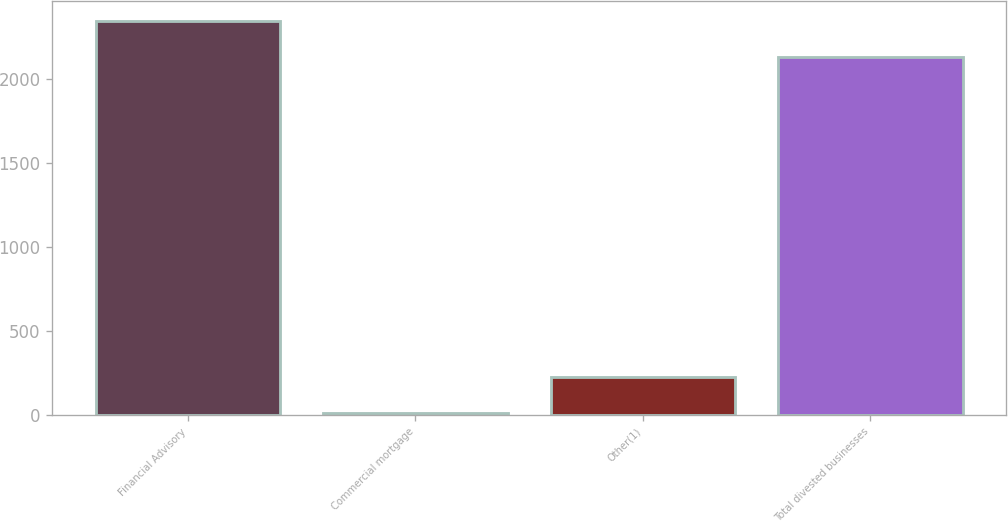Convert chart. <chart><loc_0><loc_0><loc_500><loc_500><bar_chart><fcel>Financial Advisory<fcel>Commercial mortgage<fcel>Other(1)<fcel>Total divested businesses<nl><fcel>2346.5<fcel>12<fcel>227.5<fcel>2131<nl></chart> 